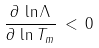<formula> <loc_0><loc_0><loc_500><loc_500>\frac { \partial \, \ln \Lambda } { \partial \, \ln T _ { m } } \, < \, 0</formula> 